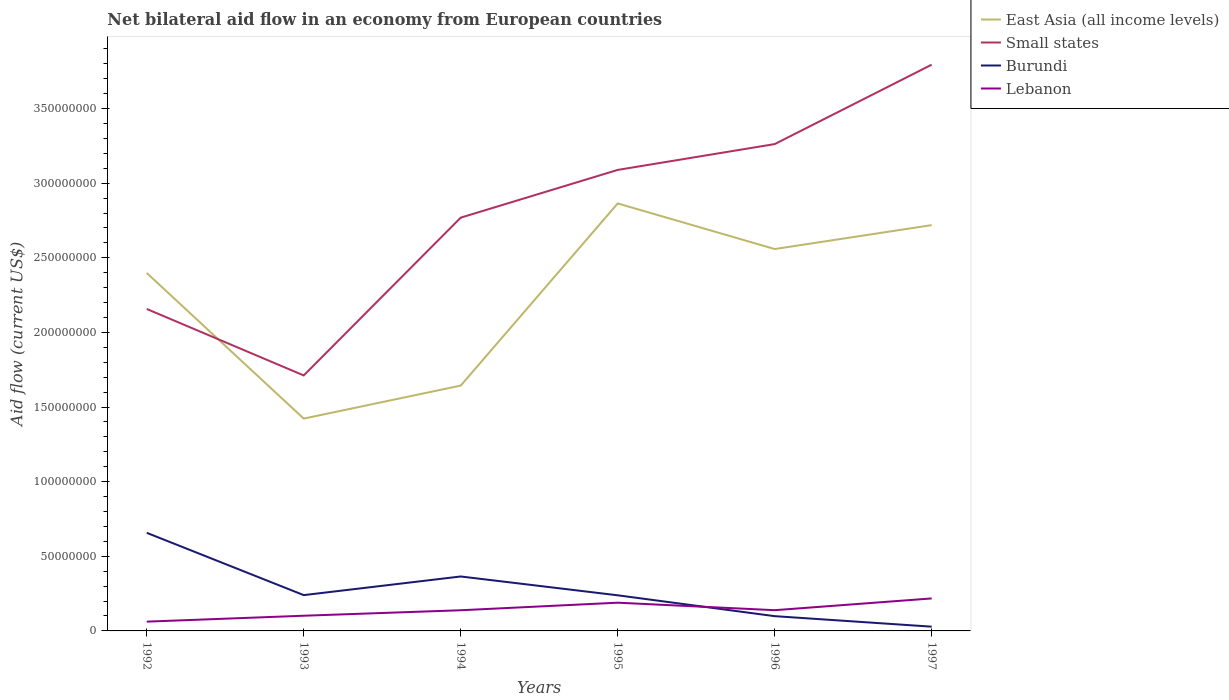How many different coloured lines are there?
Keep it short and to the point. 4. Is the number of lines equal to the number of legend labels?
Your answer should be very brief. Yes. Across all years, what is the maximum net bilateral aid flow in Lebanon?
Keep it short and to the point. 6.22e+06. In which year was the net bilateral aid flow in Lebanon maximum?
Give a very brief answer. 1992. What is the total net bilateral aid flow in Lebanon in the graph?
Provide a succinct answer. -8.74e+06. What is the difference between the highest and the second highest net bilateral aid flow in Burundi?
Provide a short and direct response. 6.29e+07. What is the difference between the highest and the lowest net bilateral aid flow in Small states?
Make the answer very short. 3. Is the net bilateral aid flow in Small states strictly greater than the net bilateral aid flow in Lebanon over the years?
Offer a terse response. No. How many lines are there?
Your answer should be very brief. 4. How many years are there in the graph?
Ensure brevity in your answer.  6. What is the difference between two consecutive major ticks on the Y-axis?
Provide a succinct answer. 5.00e+07. How many legend labels are there?
Ensure brevity in your answer.  4. What is the title of the graph?
Provide a short and direct response. Net bilateral aid flow in an economy from European countries. What is the label or title of the Y-axis?
Give a very brief answer. Aid flow (current US$). What is the Aid flow (current US$) of East Asia (all income levels) in 1992?
Your answer should be very brief. 2.40e+08. What is the Aid flow (current US$) of Small states in 1992?
Provide a short and direct response. 2.16e+08. What is the Aid flow (current US$) of Burundi in 1992?
Provide a short and direct response. 6.57e+07. What is the Aid flow (current US$) in Lebanon in 1992?
Your answer should be very brief. 6.22e+06. What is the Aid flow (current US$) of East Asia (all income levels) in 1993?
Your response must be concise. 1.42e+08. What is the Aid flow (current US$) of Small states in 1993?
Ensure brevity in your answer.  1.71e+08. What is the Aid flow (current US$) of Burundi in 1993?
Ensure brevity in your answer.  2.40e+07. What is the Aid flow (current US$) in Lebanon in 1993?
Offer a very short reply. 1.02e+07. What is the Aid flow (current US$) in East Asia (all income levels) in 1994?
Ensure brevity in your answer.  1.64e+08. What is the Aid flow (current US$) in Small states in 1994?
Keep it short and to the point. 2.77e+08. What is the Aid flow (current US$) in Burundi in 1994?
Offer a terse response. 3.65e+07. What is the Aid flow (current US$) of Lebanon in 1994?
Give a very brief answer. 1.38e+07. What is the Aid flow (current US$) of East Asia (all income levels) in 1995?
Give a very brief answer. 2.86e+08. What is the Aid flow (current US$) in Small states in 1995?
Give a very brief answer. 3.09e+08. What is the Aid flow (current US$) in Burundi in 1995?
Give a very brief answer. 2.39e+07. What is the Aid flow (current US$) of Lebanon in 1995?
Your answer should be compact. 1.89e+07. What is the Aid flow (current US$) in East Asia (all income levels) in 1996?
Your answer should be compact. 2.56e+08. What is the Aid flow (current US$) of Small states in 1996?
Your answer should be very brief. 3.26e+08. What is the Aid flow (current US$) in Burundi in 1996?
Provide a short and direct response. 9.89e+06. What is the Aid flow (current US$) of Lebanon in 1996?
Offer a terse response. 1.39e+07. What is the Aid flow (current US$) in East Asia (all income levels) in 1997?
Make the answer very short. 2.72e+08. What is the Aid flow (current US$) in Small states in 1997?
Make the answer very short. 3.79e+08. What is the Aid flow (current US$) in Burundi in 1997?
Make the answer very short. 2.85e+06. What is the Aid flow (current US$) in Lebanon in 1997?
Keep it short and to the point. 2.18e+07. Across all years, what is the maximum Aid flow (current US$) in East Asia (all income levels)?
Provide a succinct answer. 2.86e+08. Across all years, what is the maximum Aid flow (current US$) in Small states?
Make the answer very short. 3.79e+08. Across all years, what is the maximum Aid flow (current US$) in Burundi?
Make the answer very short. 6.57e+07. Across all years, what is the maximum Aid flow (current US$) of Lebanon?
Provide a short and direct response. 2.18e+07. Across all years, what is the minimum Aid flow (current US$) in East Asia (all income levels)?
Give a very brief answer. 1.42e+08. Across all years, what is the minimum Aid flow (current US$) of Small states?
Keep it short and to the point. 1.71e+08. Across all years, what is the minimum Aid flow (current US$) in Burundi?
Offer a very short reply. 2.85e+06. Across all years, what is the minimum Aid flow (current US$) in Lebanon?
Offer a very short reply. 6.22e+06. What is the total Aid flow (current US$) of East Asia (all income levels) in the graph?
Offer a very short reply. 1.36e+09. What is the total Aid flow (current US$) of Small states in the graph?
Offer a terse response. 1.68e+09. What is the total Aid flow (current US$) of Burundi in the graph?
Make the answer very short. 1.63e+08. What is the total Aid flow (current US$) of Lebanon in the graph?
Keep it short and to the point. 8.48e+07. What is the difference between the Aid flow (current US$) in East Asia (all income levels) in 1992 and that in 1993?
Your answer should be compact. 9.76e+07. What is the difference between the Aid flow (current US$) in Small states in 1992 and that in 1993?
Offer a terse response. 4.45e+07. What is the difference between the Aid flow (current US$) of Burundi in 1992 and that in 1993?
Your answer should be compact. 4.17e+07. What is the difference between the Aid flow (current US$) of Lebanon in 1992 and that in 1993?
Offer a very short reply. -3.96e+06. What is the difference between the Aid flow (current US$) in East Asia (all income levels) in 1992 and that in 1994?
Your answer should be very brief. 7.54e+07. What is the difference between the Aid flow (current US$) in Small states in 1992 and that in 1994?
Offer a terse response. -6.12e+07. What is the difference between the Aid flow (current US$) of Burundi in 1992 and that in 1994?
Provide a short and direct response. 2.92e+07. What is the difference between the Aid flow (current US$) of Lebanon in 1992 and that in 1994?
Keep it short and to the point. -7.63e+06. What is the difference between the Aid flow (current US$) of East Asia (all income levels) in 1992 and that in 1995?
Your response must be concise. -4.66e+07. What is the difference between the Aid flow (current US$) in Small states in 1992 and that in 1995?
Your response must be concise. -9.32e+07. What is the difference between the Aid flow (current US$) of Burundi in 1992 and that in 1995?
Ensure brevity in your answer.  4.19e+07. What is the difference between the Aid flow (current US$) in Lebanon in 1992 and that in 1995?
Offer a very short reply. -1.27e+07. What is the difference between the Aid flow (current US$) of East Asia (all income levels) in 1992 and that in 1996?
Ensure brevity in your answer.  -1.60e+07. What is the difference between the Aid flow (current US$) in Small states in 1992 and that in 1996?
Your answer should be very brief. -1.10e+08. What is the difference between the Aid flow (current US$) of Burundi in 1992 and that in 1996?
Your response must be concise. 5.58e+07. What is the difference between the Aid flow (current US$) of Lebanon in 1992 and that in 1996?
Offer a terse response. -7.67e+06. What is the difference between the Aid flow (current US$) of East Asia (all income levels) in 1992 and that in 1997?
Give a very brief answer. -3.21e+07. What is the difference between the Aid flow (current US$) in Small states in 1992 and that in 1997?
Provide a short and direct response. -1.64e+08. What is the difference between the Aid flow (current US$) of Burundi in 1992 and that in 1997?
Give a very brief answer. 6.29e+07. What is the difference between the Aid flow (current US$) in Lebanon in 1992 and that in 1997?
Your answer should be compact. -1.56e+07. What is the difference between the Aid flow (current US$) of East Asia (all income levels) in 1993 and that in 1994?
Give a very brief answer. -2.21e+07. What is the difference between the Aid flow (current US$) of Small states in 1993 and that in 1994?
Keep it short and to the point. -1.06e+08. What is the difference between the Aid flow (current US$) in Burundi in 1993 and that in 1994?
Provide a short and direct response. -1.25e+07. What is the difference between the Aid flow (current US$) of Lebanon in 1993 and that in 1994?
Your answer should be compact. -3.67e+06. What is the difference between the Aid flow (current US$) of East Asia (all income levels) in 1993 and that in 1995?
Your response must be concise. -1.44e+08. What is the difference between the Aid flow (current US$) of Small states in 1993 and that in 1995?
Make the answer very short. -1.38e+08. What is the difference between the Aid flow (current US$) of Burundi in 1993 and that in 1995?
Ensure brevity in your answer.  1.30e+05. What is the difference between the Aid flow (current US$) of Lebanon in 1993 and that in 1995?
Ensure brevity in your answer.  -8.74e+06. What is the difference between the Aid flow (current US$) in East Asia (all income levels) in 1993 and that in 1996?
Offer a very short reply. -1.14e+08. What is the difference between the Aid flow (current US$) of Small states in 1993 and that in 1996?
Offer a very short reply. -1.55e+08. What is the difference between the Aid flow (current US$) in Burundi in 1993 and that in 1996?
Your response must be concise. 1.41e+07. What is the difference between the Aid flow (current US$) of Lebanon in 1993 and that in 1996?
Keep it short and to the point. -3.71e+06. What is the difference between the Aid flow (current US$) of East Asia (all income levels) in 1993 and that in 1997?
Your response must be concise. -1.30e+08. What is the difference between the Aid flow (current US$) of Small states in 1993 and that in 1997?
Offer a terse response. -2.08e+08. What is the difference between the Aid flow (current US$) in Burundi in 1993 and that in 1997?
Your answer should be compact. 2.11e+07. What is the difference between the Aid flow (current US$) of Lebanon in 1993 and that in 1997?
Ensure brevity in your answer.  -1.16e+07. What is the difference between the Aid flow (current US$) of East Asia (all income levels) in 1994 and that in 1995?
Provide a succinct answer. -1.22e+08. What is the difference between the Aid flow (current US$) of Small states in 1994 and that in 1995?
Your answer should be compact. -3.20e+07. What is the difference between the Aid flow (current US$) in Burundi in 1994 and that in 1995?
Your response must be concise. 1.26e+07. What is the difference between the Aid flow (current US$) of Lebanon in 1994 and that in 1995?
Offer a terse response. -5.07e+06. What is the difference between the Aid flow (current US$) of East Asia (all income levels) in 1994 and that in 1996?
Provide a succinct answer. -9.15e+07. What is the difference between the Aid flow (current US$) of Small states in 1994 and that in 1996?
Your answer should be compact. -4.93e+07. What is the difference between the Aid flow (current US$) in Burundi in 1994 and that in 1996?
Ensure brevity in your answer.  2.66e+07. What is the difference between the Aid flow (current US$) in Lebanon in 1994 and that in 1996?
Ensure brevity in your answer.  -4.00e+04. What is the difference between the Aid flow (current US$) of East Asia (all income levels) in 1994 and that in 1997?
Provide a short and direct response. -1.08e+08. What is the difference between the Aid flow (current US$) in Small states in 1994 and that in 1997?
Give a very brief answer. -1.02e+08. What is the difference between the Aid flow (current US$) in Burundi in 1994 and that in 1997?
Offer a terse response. 3.36e+07. What is the difference between the Aid flow (current US$) of Lebanon in 1994 and that in 1997?
Offer a very short reply. -7.92e+06. What is the difference between the Aid flow (current US$) in East Asia (all income levels) in 1995 and that in 1996?
Your answer should be very brief. 3.06e+07. What is the difference between the Aid flow (current US$) of Small states in 1995 and that in 1996?
Offer a very short reply. -1.73e+07. What is the difference between the Aid flow (current US$) in Burundi in 1995 and that in 1996?
Your response must be concise. 1.40e+07. What is the difference between the Aid flow (current US$) in Lebanon in 1995 and that in 1996?
Provide a short and direct response. 5.03e+06. What is the difference between the Aid flow (current US$) in East Asia (all income levels) in 1995 and that in 1997?
Your answer should be very brief. 1.45e+07. What is the difference between the Aid flow (current US$) of Small states in 1995 and that in 1997?
Offer a terse response. -7.05e+07. What is the difference between the Aid flow (current US$) of Burundi in 1995 and that in 1997?
Keep it short and to the point. 2.10e+07. What is the difference between the Aid flow (current US$) in Lebanon in 1995 and that in 1997?
Give a very brief answer. -2.85e+06. What is the difference between the Aid flow (current US$) in East Asia (all income levels) in 1996 and that in 1997?
Offer a very short reply. -1.60e+07. What is the difference between the Aid flow (current US$) of Small states in 1996 and that in 1997?
Your response must be concise. -5.32e+07. What is the difference between the Aid flow (current US$) in Burundi in 1996 and that in 1997?
Your answer should be compact. 7.04e+06. What is the difference between the Aid flow (current US$) of Lebanon in 1996 and that in 1997?
Ensure brevity in your answer.  -7.88e+06. What is the difference between the Aid flow (current US$) in East Asia (all income levels) in 1992 and the Aid flow (current US$) in Small states in 1993?
Offer a very short reply. 6.86e+07. What is the difference between the Aid flow (current US$) of East Asia (all income levels) in 1992 and the Aid flow (current US$) of Burundi in 1993?
Your answer should be very brief. 2.16e+08. What is the difference between the Aid flow (current US$) in East Asia (all income levels) in 1992 and the Aid flow (current US$) in Lebanon in 1993?
Ensure brevity in your answer.  2.30e+08. What is the difference between the Aid flow (current US$) in Small states in 1992 and the Aid flow (current US$) in Burundi in 1993?
Offer a very short reply. 1.92e+08. What is the difference between the Aid flow (current US$) in Small states in 1992 and the Aid flow (current US$) in Lebanon in 1993?
Make the answer very short. 2.06e+08. What is the difference between the Aid flow (current US$) in Burundi in 1992 and the Aid flow (current US$) in Lebanon in 1993?
Give a very brief answer. 5.56e+07. What is the difference between the Aid flow (current US$) in East Asia (all income levels) in 1992 and the Aid flow (current US$) in Small states in 1994?
Give a very brief answer. -3.71e+07. What is the difference between the Aid flow (current US$) of East Asia (all income levels) in 1992 and the Aid flow (current US$) of Burundi in 1994?
Offer a very short reply. 2.03e+08. What is the difference between the Aid flow (current US$) in East Asia (all income levels) in 1992 and the Aid flow (current US$) in Lebanon in 1994?
Ensure brevity in your answer.  2.26e+08. What is the difference between the Aid flow (current US$) in Small states in 1992 and the Aid flow (current US$) in Burundi in 1994?
Keep it short and to the point. 1.79e+08. What is the difference between the Aid flow (current US$) of Small states in 1992 and the Aid flow (current US$) of Lebanon in 1994?
Your answer should be compact. 2.02e+08. What is the difference between the Aid flow (current US$) of Burundi in 1992 and the Aid flow (current US$) of Lebanon in 1994?
Offer a terse response. 5.19e+07. What is the difference between the Aid flow (current US$) in East Asia (all income levels) in 1992 and the Aid flow (current US$) in Small states in 1995?
Give a very brief answer. -6.90e+07. What is the difference between the Aid flow (current US$) in East Asia (all income levels) in 1992 and the Aid flow (current US$) in Burundi in 1995?
Give a very brief answer. 2.16e+08. What is the difference between the Aid flow (current US$) in East Asia (all income levels) in 1992 and the Aid flow (current US$) in Lebanon in 1995?
Offer a terse response. 2.21e+08. What is the difference between the Aid flow (current US$) in Small states in 1992 and the Aid flow (current US$) in Burundi in 1995?
Give a very brief answer. 1.92e+08. What is the difference between the Aid flow (current US$) of Small states in 1992 and the Aid flow (current US$) of Lebanon in 1995?
Give a very brief answer. 1.97e+08. What is the difference between the Aid flow (current US$) of Burundi in 1992 and the Aid flow (current US$) of Lebanon in 1995?
Ensure brevity in your answer.  4.68e+07. What is the difference between the Aid flow (current US$) in East Asia (all income levels) in 1992 and the Aid flow (current US$) in Small states in 1996?
Make the answer very short. -8.64e+07. What is the difference between the Aid flow (current US$) of East Asia (all income levels) in 1992 and the Aid flow (current US$) of Burundi in 1996?
Keep it short and to the point. 2.30e+08. What is the difference between the Aid flow (current US$) of East Asia (all income levels) in 1992 and the Aid flow (current US$) of Lebanon in 1996?
Your response must be concise. 2.26e+08. What is the difference between the Aid flow (current US$) of Small states in 1992 and the Aid flow (current US$) of Burundi in 1996?
Provide a succinct answer. 2.06e+08. What is the difference between the Aid flow (current US$) of Small states in 1992 and the Aid flow (current US$) of Lebanon in 1996?
Ensure brevity in your answer.  2.02e+08. What is the difference between the Aid flow (current US$) in Burundi in 1992 and the Aid flow (current US$) in Lebanon in 1996?
Make the answer very short. 5.18e+07. What is the difference between the Aid flow (current US$) of East Asia (all income levels) in 1992 and the Aid flow (current US$) of Small states in 1997?
Ensure brevity in your answer.  -1.40e+08. What is the difference between the Aid flow (current US$) of East Asia (all income levels) in 1992 and the Aid flow (current US$) of Burundi in 1997?
Provide a short and direct response. 2.37e+08. What is the difference between the Aid flow (current US$) in East Asia (all income levels) in 1992 and the Aid flow (current US$) in Lebanon in 1997?
Ensure brevity in your answer.  2.18e+08. What is the difference between the Aid flow (current US$) of Small states in 1992 and the Aid flow (current US$) of Burundi in 1997?
Offer a very short reply. 2.13e+08. What is the difference between the Aid flow (current US$) of Small states in 1992 and the Aid flow (current US$) of Lebanon in 1997?
Make the answer very short. 1.94e+08. What is the difference between the Aid flow (current US$) of Burundi in 1992 and the Aid flow (current US$) of Lebanon in 1997?
Your answer should be very brief. 4.40e+07. What is the difference between the Aid flow (current US$) in East Asia (all income levels) in 1993 and the Aid flow (current US$) in Small states in 1994?
Provide a short and direct response. -1.35e+08. What is the difference between the Aid flow (current US$) in East Asia (all income levels) in 1993 and the Aid flow (current US$) in Burundi in 1994?
Ensure brevity in your answer.  1.06e+08. What is the difference between the Aid flow (current US$) in East Asia (all income levels) in 1993 and the Aid flow (current US$) in Lebanon in 1994?
Provide a short and direct response. 1.28e+08. What is the difference between the Aid flow (current US$) in Small states in 1993 and the Aid flow (current US$) in Burundi in 1994?
Give a very brief answer. 1.35e+08. What is the difference between the Aid flow (current US$) in Small states in 1993 and the Aid flow (current US$) in Lebanon in 1994?
Your answer should be compact. 1.57e+08. What is the difference between the Aid flow (current US$) in Burundi in 1993 and the Aid flow (current US$) in Lebanon in 1994?
Your response must be concise. 1.01e+07. What is the difference between the Aid flow (current US$) in East Asia (all income levels) in 1993 and the Aid flow (current US$) in Small states in 1995?
Provide a short and direct response. -1.67e+08. What is the difference between the Aid flow (current US$) of East Asia (all income levels) in 1993 and the Aid flow (current US$) of Burundi in 1995?
Your response must be concise. 1.18e+08. What is the difference between the Aid flow (current US$) of East Asia (all income levels) in 1993 and the Aid flow (current US$) of Lebanon in 1995?
Your answer should be compact. 1.23e+08. What is the difference between the Aid flow (current US$) of Small states in 1993 and the Aid flow (current US$) of Burundi in 1995?
Provide a succinct answer. 1.47e+08. What is the difference between the Aid flow (current US$) of Small states in 1993 and the Aid flow (current US$) of Lebanon in 1995?
Your response must be concise. 1.52e+08. What is the difference between the Aid flow (current US$) of Burundi in 1993 and the Aid flow (current US$) of Lebanon in 1995?
Give a very brief answer. 5.07e+06. What is the difference between the Aid flow (current US$) in East Asia (all income levels) in 1993 and the Aid flow (current US$) in Small states in 1996?
Provide a short and direct response. -1.84e+08. What is the difference between the Aid flow (current US$) of East Asia (all income levels) in 1993 and the Aid flow (current US$) of Burundi in 1996?
Offer a terse response. 1.32e+08. What is the difference between the Aid flow (current US$) in East Asia (all income levels) in 1993 and the Aid flow (current US$) in Lebanon in 1996?
Ensure brevity in your answer.  1.28e+08. What is the difference between the Aid flow (current US$) of Small states in 1993 and the Aid flow (current US$) of Burundi in 1996?
Provide a short and direct response. 1.61e+08. What is the difference between the Aid flow (current US$) of Small states in 1993 and the Aid flow (current US$) of Lebanon in 1996?
Provide a short and direct response. 1.57e+08. What is the difference between the Aid flow (current US$) of Burundi in 1993 and the Aid flow (current US$) of Lebanon in 1996?
Offer a very short reply. 1.01e+07. What is the difference between the Aid flow (current US$) in East Asia (all income levels) in 1993 and the Aid flow (current US$) in Small states in 1997?
Give a very brief answer. -2.37e+08. What is the difference between the Aid flow (current US$) in East Asia (all income levels) in 1993 and the Aid flow (current US$) in Burundi in 1997?
Give a very brief answer. 1.39e+08. What is the difference between the Aid flow (current US$) of East Asia (all income levels) in 1993 and the Aid flow (current US$) of Lebanon in 1997?
Make the answer very short. 1.20e+08. What is the difference between the Aid flow (current US$) of Small states in 1993 and the Aid flow (current US$) of Burundi in 1997?
Offer a very short reply. 1.68e+08. What is the difference between the Aid flow (current US$) of Small states in 1993 and the Aid flow (current US$) of Lebanon in 1997?
Provide a succinct answer. 1.49e+08. What is the difference between the Aid flow (current US$) of Burundi in 1993 and the Aid flow (current US$) of Lebanon in 1997?
Offer a very short reply. 2.22e+06. What is the difference between the Aid flow (current US$) in East Asia (all income levels) in 1994 and the Aid flow (current US$) in Small states in 1995?
Provide a succinct answer. -1.44e+08. What is the difference between the Aid flow (current US$) in East Asia (all income levels) in 1994 and the Aid flow (current US$) in Burundi in 1995?
Offer a very short reply. 1.41e+08. What is the difference between the Aid flow (current US$) in East Asia (all income levels) in 1994 and the Aid flow (current US$) in Lebanon in 1995?
Your answer should be compact. 1.45e+08. What is the difference between the Aid flow (current US$) in Small states in 1994 and the Aid flow (current US$) in Burundi in 1995?
Make the answer very short. 2.53e+08. What is the difference between the Aid flow (current US$) of Small states in 1994 and the Aid flow (current US$) of Lebanon in 1995?
Give a very brief answer. 2.58e+08. What is the difference between the Aid flow (current US$) of Burundi in 1994 and the Aid flow (current US$) of Lebanon in 1995?
Keep it short and to the point. 1.76e+07. What is the difference between the Aid flow (current US$) in East Asia (all income levels) in 1994 and the Aid flow (current US$) in Small states in 1996?
Offer a very short reply. -1.62e+08. What is the difference between the Aid flow (current US$) in East Asia (all income levels) in 1994 and the Aid flow (current US$) in Burundi in 1996?
Your answer should be very brief. 1.54e+08. What is the difference between the Aid flow (current US$) of East Asia (all income levels) in 1994 and the Aid flow (current US$) of Lebanon in 1996?
Your answer should be compact. 1.50e+08. What is the difference between the Aid flow (current US$) of Small states in 1994 and the Aid flow (current US$) of Burundi in 1996?
Provide a succinct answer. 2.67e+08. What is the difference between the Aid flow (current US$) of Small states in 1994 and the Aid flow (current US$) of Lebanon in 1996?
Your answer should be compact. 2.63e+08. What is the difference between the Aid flow (current US$) of Burundi in 1994 and the Aid flow (current US$) of Lebanon in 1996?
Make the answer very short. 2.26e+07. What is the difference between the Aid flow (current US$) of East Asia (all income levels) in 1994 and the Aid flow (current US$) of Small states in 1997?
Your answer should be compact. -2.15e+08. What is the difference between the Aid flow (current US$) in East Asia (all income levels) in 1994 and the Aid flow (current US$) in Burundi in 1997?
Make the answer very short. 1.62e+08. What is the difference between the Aid flow (current US$) in East Asia (all income levels) in 1994 and the Aid flow (current US$) in Lebanon in 1997?
Offer a terse response. 1.43e+08. What is the difference between the Aid flow (current US$) in Small states in 1994 and the Aid flow (current US$) in Burundi in 1997?
Your response must be concise. 2.74e+08. What is the difference between the Aid flow (current US$) in Small states in 1994 and the Aid flow (current US$) in Lebanon in 1997?
Give a very brief answer. 2.55e+08. What is the difference between the Aid flow (current US$) in Burundi in 1994 and the Aid flow (current US$) in Lebanon in 1997?
Make the answer very short. 1.47e+07. What is the difference between the Aid flow (current US$) of East Asia (all income levels) in 1995 and the Aid flow (current US$) of Small states in 1996?
Your response must be concise. -3.98e+07. What is the difference between the Aid flow (current US$) in East Asia (all income levels) in 1995 and the Aid flow (current US$) in Burundi in 1996?
Ensure brevity in your answer.  2.77e+08. What is the difference between the Aid flow (current US$) of East Asia (all income levels) in 1995 and the Aid flow (current US$) of Lebanon in 1996?
Offer a very short reply. 2.73e+08. What is the difference between the Aid flow (current US$) of Small states in 1995 and the Aid flow (current US$) of Burundi in 1996?
Your answer should be compact. 2.99e+08. What is the difference between the Aid flow (current US$) of Small states in 1995 and the Aid flow (current US$) of Lebanon in 1996?
Provide a succinct answer. 2.95e+08. What is the difference between the Aid flow (current US$) of Burundi in 1995 and the Aid flow (current US$) of Lebanon in 1996?
Provide a short and direct response. 9.97e+06. What is the difference between the Aid flow (current US$) in East Asia (all income levels) in 1995 and the Aid flow (current US$) in Small states in 1997?
Your answer should be compact. -9.30e+07. What is the difference between the Aid flow (current US$) in East Asia (all income levels) in 1995 and the Aid flow (current US$) in Burundi in 1997?
Offer a very short reply. 2.84e+08. What is the difference between the Aid flow (current US$) in East Asia (all income levels) in 1995 and the Aid flow (current US$) in Lebanon in 1997?
Provide a succinct answer. 2.65e+08. What is the difference between the Aid flow (current US$) of Small states in 1995 and the Aid flow (current US$) of Burundi in 1997?
Offer a very short reply. 3.06e+08. What is the difference between the Aid flow (current US$) in Small states in 1995 and the Aid flow (current US$) in Lebanon in 1997?
Give a very brief answer. 2.87e+08. What is the difference between the Aid flow (current US$) in Burundi in 1995 and the Aid flow (current US$) in Lebanon in 1997?
Your response must be concise. 2.09e+06. What is the difference between the Aid flow (current US$) of East Asia (all income levels) in 1996 and the Aid flow (current US$) of Small states in 1997?
Keep it short and to the point. -1.24e+08. What is the difference between the Aid flow (current US$) in East Asia (all income levels) in 1996 and the Aid flow (current US$) in Burundi in 1997?
Provide a short and direct response. 2.53e+08. What is the difference between the Aid flow (current US$) of East Asia (all income levels) in 1996 and the Aid flow (current US$) of Lebanon in 1997?
Provide a succinct answer. 2.34e+08. What is the difference between the Aid flow (current US$) of Small states in 1996 and the Aid flow (current US$) of Burundi in 1997?
Your response must be concise. 3.23e+08. What is the difference between the Aid flow (current US$) of Small states in 1996 and the Aid flow (current US$) of Lebanon in 1997?
Provide a short and direct response. 3.04e+08. What is the difference between the Aid flow (current US$) in Burundi in 1996 and the Aid flow (current US$) in Lebanon in 1997?
Your answer should be very brief. -1.19e+07. What is the average Aid flow (current US$) in East Asia (all income levels) per year?
Offer a very short reply. 2.27e+08. What is the average Aid flow (current US$) of Small states per year?
Your answer should be very brief. 2.80e+08. What is the average Aid flow (current US$) of Burundi per year?
Offer a terse response. 2.71e+07. What is the average Aid flow (current US$) in Lebanon per year?
Offer a very short reply. 1.41e+07. In the year 1992, what is the difference between the Aid flow (current US$) in East Asia (all income levels) and Aid flow (current US$) in Small states?
Give a very brief answer. 2.41e+07. In the year 1992, what is the difference between the Aid flow (current US$) in East Asia (all income levels) and Aid flow (current US$) in Burundi?
Make the answer very short. 1.74e+08. In the year 1992, what is the difference between the Aid flow (current US$) of East Asia (all income levels) and Aid flow (current US$) of Lebanon?
Your answer should be very brief. 2.34e+08. In the year 1992, what is the difference between the Aid flow (current US$) of Small states and Aid flow (current US$) of Burundi?
Keep it short and to the point. 1.50e+08. In the year 1992, what is the difference between the Aid flow (current US$) in Small states and Aid flow (current US$) in Lebanon?
Make the answer very short. 2.09e+08. In the year 1992, what is the difference between the Aid flow (current US$) in Burundi and Aid flow (current US$) in Lebanon?
Make the answer very short. 5.95e+07. In the year 1993, what is the difference between the Aid flow (current US$) in East Asia (all income levels) and Aid flow (current US$) in Small states?
Your response must be concise. -2.89e+07. In the year 1993, what is the difference between the Aid flow (current US$) in East Asia (all income levels) and Aid flow (current US$) in Burundi?
Provide a succinct answer. 1.18e+08. In the year 1993, what is the difference between the Aid flow (current US$) of East Asia (all income levels) and Aid flow (current US$) of Lebanon?
Provide a succinct answer. 1.32e+08. In the year 1993, what is the difference between the Aid flow (current US$) in Small states and Aid flow (current US$) in Burundi?
Offer a terse response. 1.47e+08. In the year 1993, what is the difference between the Aid flow (current US$) in Small states and Aid flow (current US$) in Lebanon?
Offer a very short reply. 1.61e+08. In the year 1993, what is the difference between the Aid flow (current US$) in Burundi and Aid flow (current US$) in Lebanon?
Your answer should be very brief. 1.38e+07. In the year 1994, what is the difference between the Aid flow (current US$) of East Asia (all income levels) and Aid flow (current US$) of Small states?
Ensure brevity in your answer.  -1.13e+08. In the year 1994, what is the difference between the Aid flow (current US$) in East Asia (all income levels) and Aid flow (current US$) in Burundi?
Offer a terse response. 1.28e+08. In the year 1994, what is the difference between the Aid flow (current US$) in East Asia (all income levels) and Aid flow (current US$) in Lebanon?
Offer a terse response. 1.51e+08. In the year 1994, what is the difference between the Aid flow (current US$) in Small states and Aid flow (current US$) in Burundi?
Your answer should be very brief. 2.40e+08. In the year 1994, what is the difference between the Aid flow (current US$) of Small states and Aid flow (current US$) of Lebanon?
Provide a short and direct response. 2.63e+08. In the year 1994, what is the difference between the Aid flow (current US$) of Burundi and Aid flow (current US$) of Lebanon?
Provide a short and direct response. 2.26e+07. In the year 1995, what is the difference between the Aid flow (current US$) in East Asia (all income levels) and Aid flow (current US$) in Small states?
Provide a succinct answer. -2.25e+07. In the year 1995, what is the difference between the Aid flow (current US$) in East Asia (all income levels) and Aid flow (current US$) in Burundi?
Your answer should be very brief. 2.63e+08. In the year 1995, what is the difference between the Aid flow (current US$) in East Asia (all income levels) and Aid flow (current US$) in Lebanon?
Your answer should be very brief. 2.67e+08. In the year 1995, what is the difference between the Aid flow (current US$) in Small states and Aid flow (current US$) in Burundi?
Your answer should be very brief. 2.85e+08. In the year 1995, what is the difference between the Aid flow (current US$) in Small states and Aid flow (current US$) in Lebanon?
Give a very brief answer. 2.90e+08. In the year 1995, what is the difference between the Aid flow (current US$) of Burundi and Aid flow (current US$) of Lebanon?
Make the answer very short. 4.94e+06. In the year 1996, what is the difference between the Aid flow (current US$) in East Asia (all income levels) and Aid flow (current US$) in Small states?
Give a very brief answer. -7.03e+07. In the year 1996, what is the difference between the Aid flow (current US$) in East Asia (all income levels) and Aid flow (current US$) in Burundi?
Offer a terse response. 2.46e+08. In the year 1996, what is the difference between the Aid flow (current US$) in East Asia (all income levels) and Aid flow (current US$) in Lebanon?
Your answer should be very brief. 2.42e+08. In the year 1996, what is the difference between the Aid flow (current US$) of Small states and Aid flow (current US$) of Burundi?
Offer a very short reply. 3.16e+08. In the year 1996, what is the difference between the Aid flow (current US$) of Small states and Aid flow (current US$) of Lebanon?
Provide a succinct answer. 3.12e+08. In the year 1997, what is the difference between the Aid flow (current US$) in East Asia (all income levels) and Aid flow (current US$) in Small states?
Your response must be concise. -1.08e+08. In the year 1997, what is the difference between the Aid flow (current US$) in East Asia (all income levels) and Aid flow (current US$) in Burundi?
Your answer should be very brief. 2.69e+08. In the year 1997, what is the difference between the Aid flow (current US$) in East Asia (all income levels) and Aid flow (current US$) in Lebanon?
Give a very brief answer. 2.50e+08. In the year 1997, what is the difference between the Aid flow (current US$) in Small states and Aid flow (current US$) in Burundi?
Provide a short and direct response. 3.77e+08. In the year 1997, what is the difference between the Aid flow (current US$) in Small states and Aid flow (current US$) in Lebanon?
Provide a succinct answer. 3.58e+08. In the year 1997, what is the difference between the Aid flow (current US$) of Burundi and Aid flow (current US$) of Lebanon?
Provide a short and direct response. -1.89e+07. What is the ratio of the Aid flow (current US$) of East Asia (all income levels) in 1992 to that in 1993?
Ensure brevity in your answer.  1.69. What is the ratio of the Aid flow (current US$) of Small states in 1992 to that in 1993?
Provide a succinct answer. 1.26. What is the ratio of the Aid flow (current US$) in Burundi in 1992 to that in 1993?
Provide a short and direct response. 2.74. What is the ratio of the Aid flow (current US$) in Lebanon in 1992 to that in 1993?
Provide a succinct answer. 0.61. What is the ratio of the Aid flow (current US$) of East Asia (all income levels) in 1992 to that in 1994?
Your answer should be very brief. 1.46. What is the ratio of the Aid flow (current US$) in Small states in 1992 to that in 1994?
Your answer should be compact. 0.78. What is the ratio of the Aid flow (current US$) in Burundi in 1992 to that in 1994?
Make the answer very short. 1.8. What is the ratio of the Aid flow (current US$) of Lebanon in 1992 to that in 1994?
Your answer should be very brief. 0.45. What is the ratio of the Aid flow (current US$) of East Asia (all income levels) in 1992 to that in 1995?
Offer a terse response. 0.84. What is the ratio of the Aid flow (current US$) in Small states in 1992 to that in 1995?
Keep it short and to the point. 0.7. What is the ratio of the Aid flow (current US$) of Burundi in 1992 to that in 1995?
Offer a terse response. 2.75. What is the ratio of the Aid flow (current US$) in Lebanon in 1992 to that in 1995?
Provide a short and direct response. 0.33. What is the ratio of the Aid flow (current US$) in East Asia (all income levels) in 1992 to that in 1996?
Give a very brief answer. 0.94. What is the ratio of the Aid flow (current US$) of Small states in 1992 to that in 1996?
Offer a terse response. 0.66. What is the ratio of the Aid flow (current US$) in Burundi in 1992 to that in 1996?
Make the answer very short. 6.65. What is the ratio of the Aid flow (current US$) in Lebanon in 1992 to that in 1996?
Give a very brief answer. 0.45. What is the ratio of the Aid flow (current US$) in East Asia (all income levels) in 1992 to that in 1997?
Provide a short and direct response. 0.88. What is the ratio of the Aid flow (current US$) of Small states in 1992 to that in 1997?
Keep it short and to the point. 0.57. What is the ratio of the Aid flow (current US$) of Burundi in 1992 to that in 1997?
Offer a terse response. 23.06. What is the ratio of the Aid flow (current US$) of Lebanon in 1992 to that in 1997?
Give a very brief answer. 0.29. What is the ratio of the Aid flow (current US$) in East Asia (all income levels) in 1993 to that in 1994?
Offer a very short reply. 0.87. What is the ratio of the Aid flow (current US$) in Small states in 1993 to that in 1994?
Ensure brevity in your answer.  0.62. What is the ratio of the Aid flow (current US$) of Burundi in 1993 to that in 1994?
Keep it short and to the point. 0.66. What is the ratio of the Aid flow (current US$) in Lebanon in 1993 to that in 1994?
Provide a succinct answer. 0.73. What is the ratio of the Aid flow (current US$) of East Asia (all income levels) in 1993 to that in 1995?
Your response must be concise. 0.5. What is the ratio of the Aid flow (current US$) of Small states in 1993 to that in 1995?
Your answer should be compact. 0.55. What is the ratio of the Aid flow (current US$) in Burundi in 1993 to that in 1995?
Provide a succinct answer. 1.01. What is the ratio of the Aid flow (current US$) in Lebanon in 1993 to that in 1995?
Provide a short and direct response. 0.54. What is the ratio of the Aid flow (current US$) of East Asia (all income levels) in 1993 to that in 1996?
Make the answer very short. 0.56. What is the ratio of the Aid flow (current US$) of Small states in 1993 to that in 1996?
Keep it short and to the point. 0.52. What is the ratio of the Aid flow (current US$) in Burundi in 1993 to that in 1996?
Your response must be concise. 2.43. What is the ratio of the Aid flow (current US$) of Lebanon in 1993 to that in 1996?
Keep it short and to the point. 0.73. What is the ratio of the Aid flow (current US$) in East Asia (all income levels) in 1993 to that in 1997?
Provide a short and direct response. 0.52. What is the ratio of the Aid flow (current US$) in Small states in 1993 to that in 1997?
Your answer should be very brief. 0.45. What is the ratio of the Aid flow (current US$) in Burundi in 1993 to that in 1997?
Provide a short and direct response. 8.42. What is the ratio of the Aid flow (current US$) of Lebanon in 1993 to that in 1997?
Your answer should be compact. 0.47. What is the ratio of the Aid flow (current US$) of East Asia (all income levels) in 1994 to that in 1995?
Provide a succinct answer. 0.57. What is the ratio of the Aid flow (current US$) of Small states in 1994 to that in 1995?
Keep it short and to the point. 0.9. What is the ratio of the Aid flow (current US$) in Burundi in 1994 to that in 1995?
Make the answer very short. 1.53. What is the ratio of the Aid flow (current US$) in Lebanon in 1994 to that in 1995?
Ensure brevity in your answer.  0.73. What is the ratio of the Aid flow (current US$) in East Asia (all income levels) in 1994 to that in 1996?
Keep it short and to the point. 0.64. What is the ratio of the Aid flow (current US$) of Small states in 1994 to that in 1996?
Offer a terse response. 0.85. What is the ratio of the Aid flow (current US$) in Burundi in 1994 to that in 1996?
Your response must be concise. 3.69. What is the ratio of the Aid flow (current US$) in East Asia (all income levels) in 1994 to that in 1997?
Offer a terse response. 0.6. What is the ratio of the Aid flow (current US$) of Small states in 1994 to that in 1997?
Provide a short and direct response. 0.73. What is the ratio of the Aid flow (current US$) of Lebanon in 1994 to that in 1997?
Offer a terse response. 0.64. What is the ratio of the Aid flow (current US$) in East Asia (all income levels) in 1995 to that in 1996?
Your answer should be compact. 1.12. What is the ratio of the Aid flow (current US$) of Small states in 1995 to that in 1996?
Ensure brevity in your answer.  0.95. What is the ratio of the Aid flow (current US$) of Burundi in 1995 to that in 1996?
Offer a terse response. 2.41. What is the ratio of the Aid flow (current US$) of Lebanon in 1995 to that in 1996?
Your answer should be compact. 1.36. What is the ratio of the Aid flow (current US$) of East Asia (all income levels) in 1995 to that in 1997?
Provide a succinct answer. 1.05. What is the ratio of the Aid flow (current US$) in Small states in 1995 to that in 1997?
Your response must be concise. 0.81. What is the ratio of the Aid flow (current US$) in Burundi in 1995 to that in 1997?
Make the answer very short. 8.37. What is the ratio of the Aid flow (current US$) of Lebanon in 1995 to that in 1997?
Provide a short and direct response. 0.87. What is the ratio of the Aid flow (current US$) in East Asia (all income levels) in 1996 to that in 1997?
Ensure brevity in your answer.  0.94. What is the ratio of the Aid flow (current US$) in Small states in 1996 to that in 1997?
Your answer should be very brief. 0.86. What is the ratio of the Aid flow (current US$) of Burundi in 1996 to that in 1997?
Your answer should be compact. 3.47. What is the ratio of the Aid flow (current US$) of Lebanon in 1996 to that in 1997?
Your answer should be very brief. 0.64. What is the difference between the highest and the second highest Aid flow (current US$) in East Asia (all income levels)?
Provide a succinct answer. 1.45e+07. What is the difference between the highest and the second highest Aid flow (current US$) of Small states?
Provide a short and direct response. 5.32e+07. What is the difference between the highest and the second highest Aid flow (current US$) of Burundi?
Provide a succinct answer. 2.92e+07. What is the difference between the highest and the second highest Aid flow (current US$) in Lebanon?
Your response must be concise. 2.85e+06. What is the difference between the highest and the lowest Aid flow (current US$) in East Asia (all income levels)?
Provide a short and direct response. 1.44e+08. What is the difference between the highest and the lowest Aid flow (current US$) in Small states?
Offer a terse response. 2.08e+08. What is the difference between the highest and the lowest Aid flow (current US$) in Burundi?
Make the answer very short. 6.29e+07. What is the difference between the highest and the lowest Aid flow (current US$) in Lebanon?
Make the answer very short. 1.56e+07. 